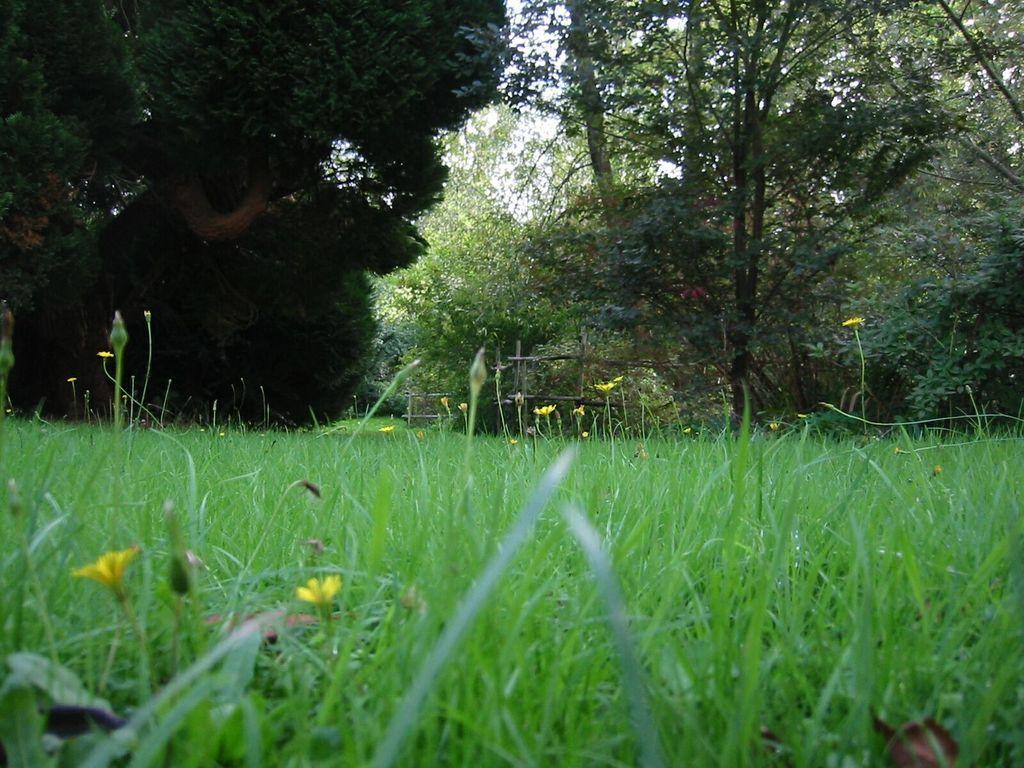What type of vegetation is present at the bottom of the image? There is grass and flowers at the bottom of the image. What else can be seen at the bottom of the image? There are no other objects or features mentioned at the bottom of the image besides the grass and flowers. What is visible in the background of the image? There are trees and the sky visible in the background of the image. What type of roof can be seen in the image? There is no roof present in the image. Is there an alley visible in the image? There is no alley present in the image. 